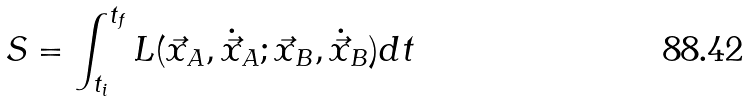<formula> <loc_0><loc_0><loc_500><loc_500>S = \int _ { t _ { i } } ^ { t _ { f } } L ( \vec { x } _ { A } , \dot { \vec { x } } _ { A } ; \vec { x } _ { B } , \dot { \vec { x } } _ { B } ) d t</formula> 